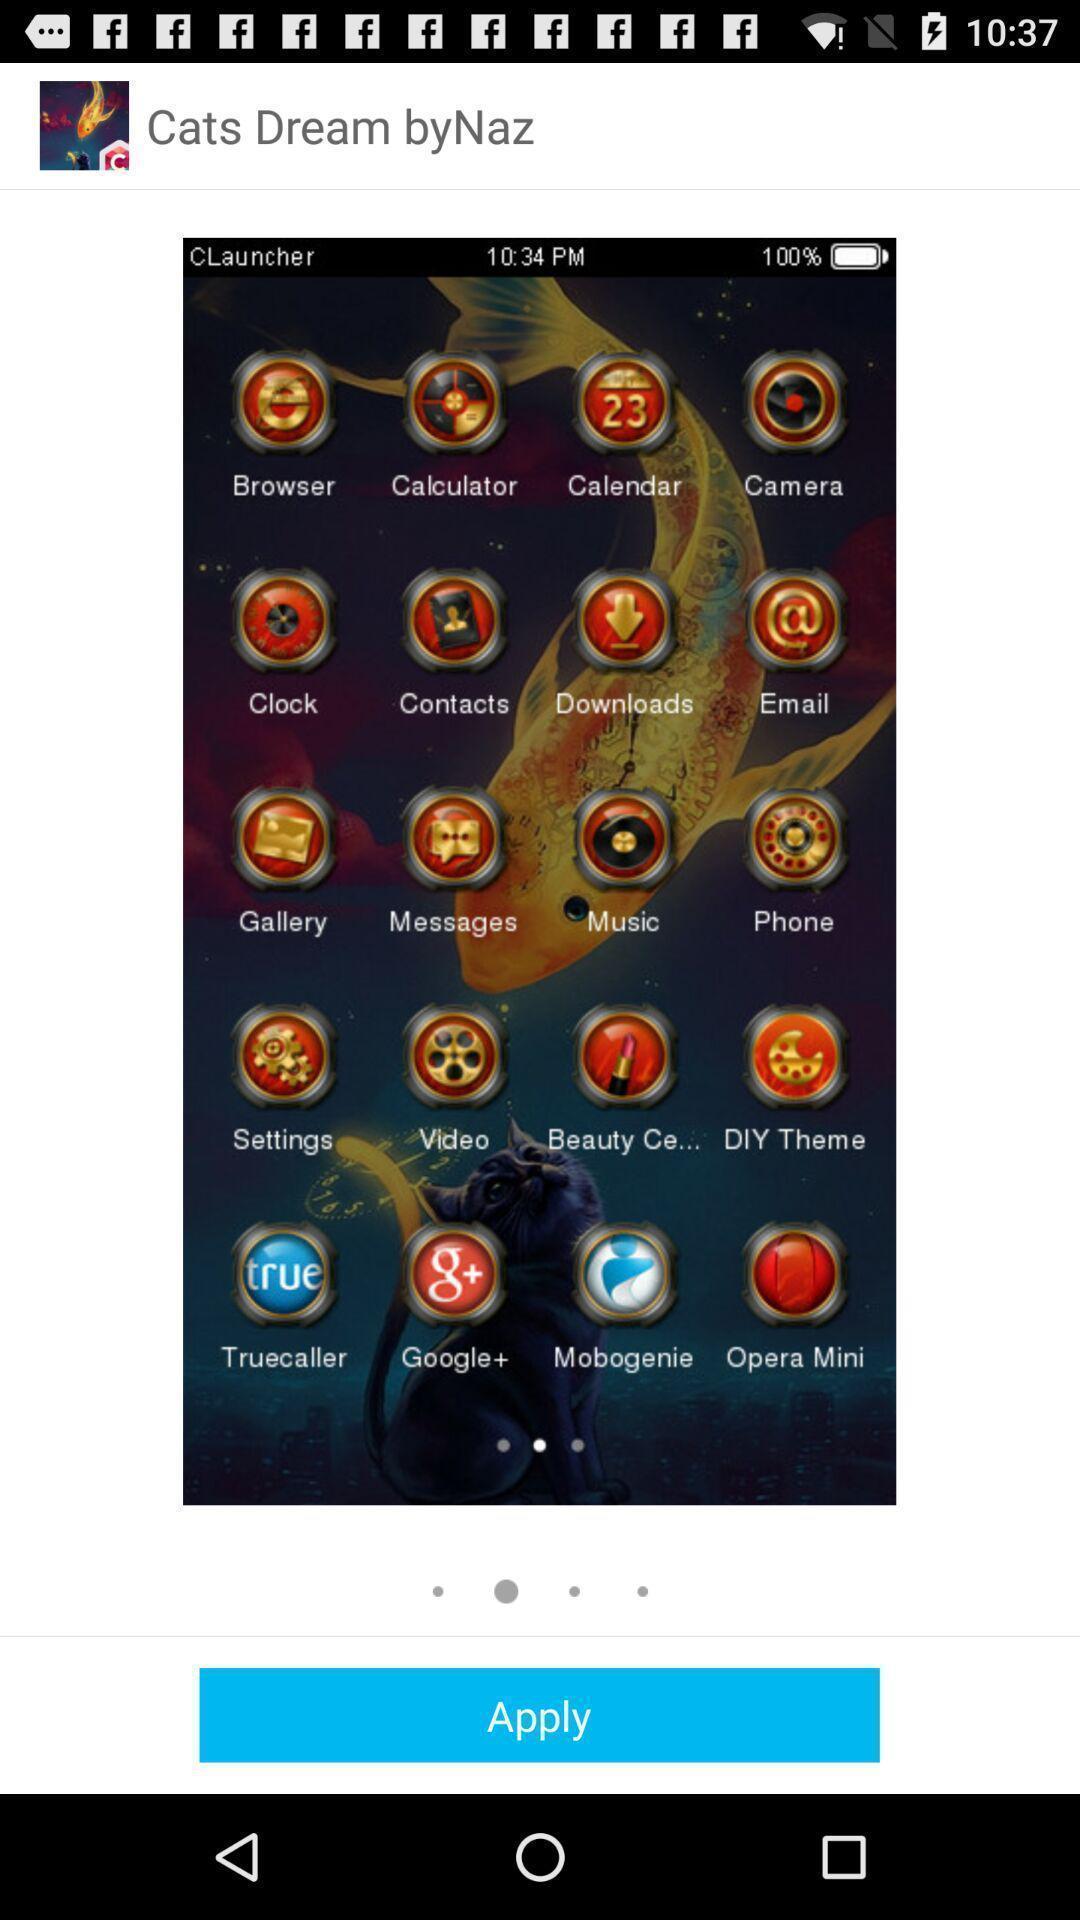Tell me what you see in this picture. Page showing the theme with various applications. 